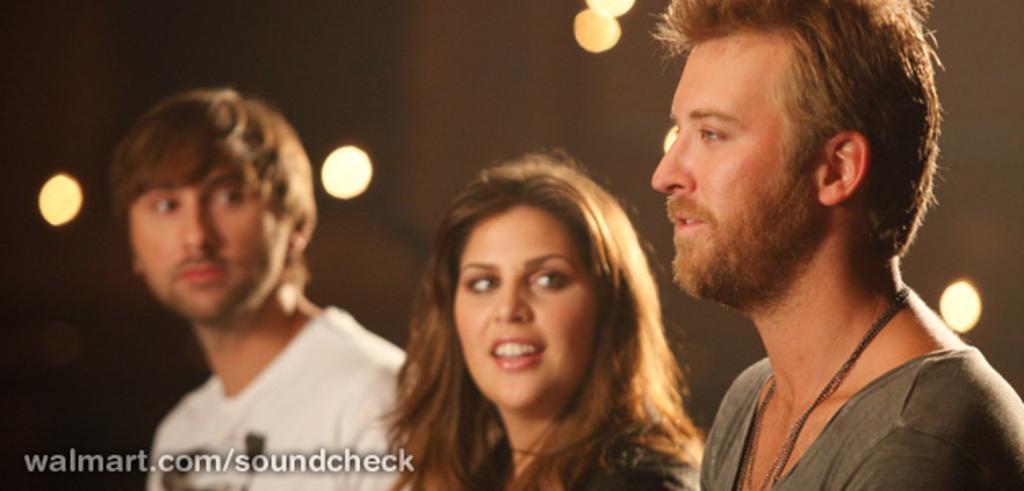Can you describe this image briefly? In this image there is a man and a woman staring into another man who is standing on their left. 